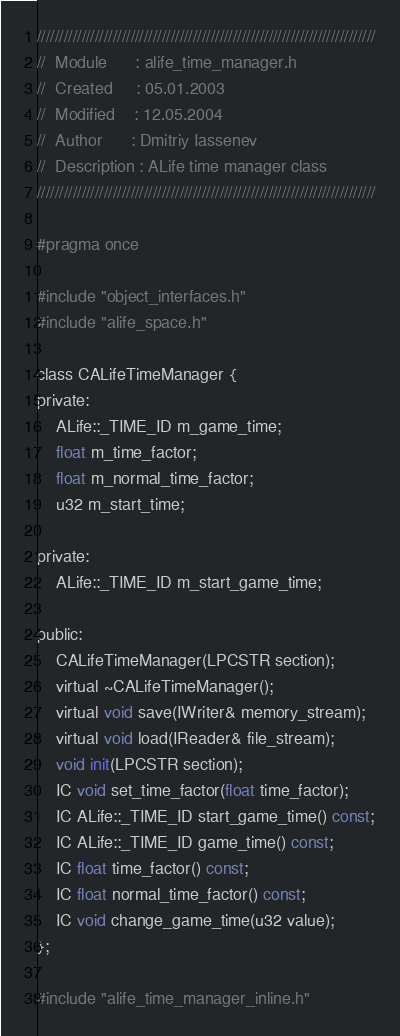Convert code to text. <code><loc_0><loc_0><loc_500><loc_500><_C_>////////////////////////////////////////////////////////////////////////////
//	Module 		: alife_time_manager.h
//	Created 	: 05.01.2003
//  Modified 	: 12.05.2004
//	Author		: Dmitriy Iassenev
//	Description : ALife time manager class
////////////////////////////////////////////////////////////////////////////

#pragma once

#include "object_interfaces.h"
#include "alife_space.h"

class CALifeTimeManager {
private:
    ALife::_TIME_ID m_game_time;
    float m_time_factor;
    float m_normal_time_factor;
    u32 m_start_time;

private:
    ALife::_TIME_ID m_start_game_time;

public:
    CALifeTimeManager(LPCSTR section);
    virtual ~CALifeTimeManager();
    virtual void save(IWriter& memory_stream);
    virtual void load(IReader& file_stream);
    void init(LPCSTR section);
    IC void set_time_factor(float time_factor);
    IC ALife::_TIME_ID start_game_time() const;
    IC ALife::_TIME_ID game_time() const;
    IC float time_factor() const;
    IC float normal_time_factor() const;
    IC void change_game_time(u32 value);
};

#include "alife_time_manager_inline.h"</code> 